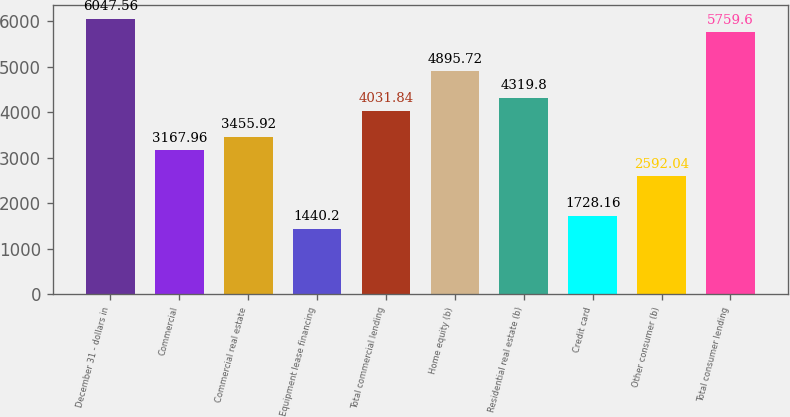Convert chart to OTSL. <chart><loc_0><loc_0><loc_500><loc_500><bar_chart><fcel>December 31 - dollars in<fcel>Commercial<fcel>Commercial real estate<fcel>Equipment lease financing<fcel>Total commercial lending<fcel>Home equity (b)<fcel>Residential real estate (b)<fcel>Credit card<fcel>Other consumer (b)<fcel>Total consumer lending<nl><fcel>6047.56<fcel>3167.96<fcel>3455.92<fcel>1440.2<fcel>4031.84<fcel>4895.72<fcel>4319.8<fcel>1728.16<fcel>2592.04<fcel>5759.6<nl></chart> 